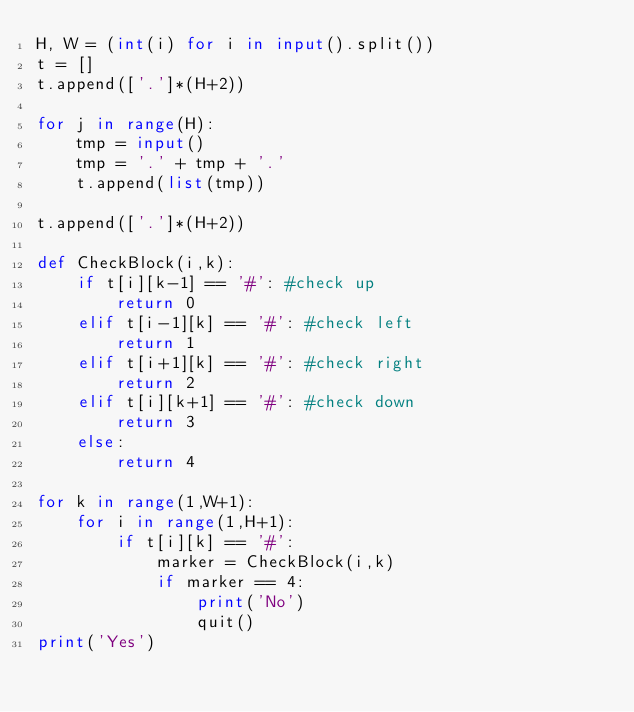Convert code to text. <code><loc_0><loc_0><loc_500><loc_500><_Python_>H, W = (int(i) for i in input().split())
t = []
t.append(['.']*(H+2))

for j in range(H):
	tmp = input()
	tmp = '.' + tmp + '.'
	t.append(list(tmp))

t.append(['.']*(H+2))

def CheckBlock(i,k):
	if t[i][k-1] == '#': #check up
		return 0
	elif t[i-1][k] == '#': #check left
		return 1
	elif t[i+1][k] == '#': #check right
		return 2
	elif t[i][k+1] == '#': #check down
		return 3
	else:
		return 4

for k in range(1,W+1):
	for i in range(1,H+1):
		if t[i][k] == '#':
			marker = CheckBlock(i,k)
			if marker == 4:
				print('No')
				quit()
print('Yes')</code> 